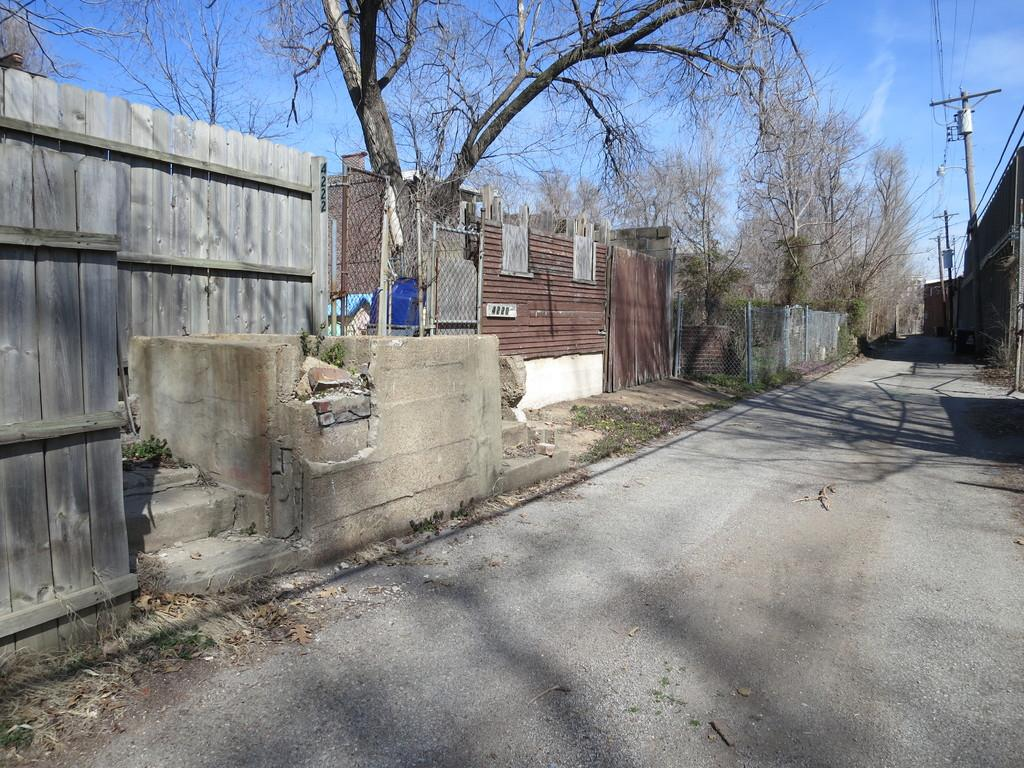What structures can be seen in the image? There are poles and a wooden fence in the image. What else is present in the image besides the structures? There are cables, a road, trees, and the sky is visible in the background of the image. Where is the sofa located in the image? There is no sofa present in the image. Can you describe the coastline visible in the image? There is no coastline visible in the image; it features poles, a wooden fence, cables, a road, trees, and the sky. 